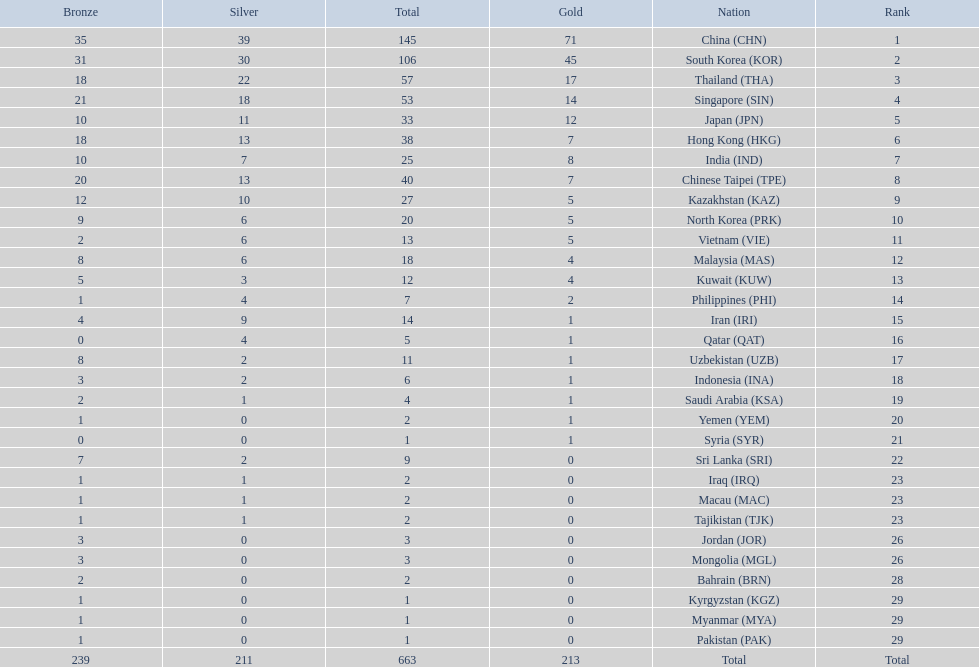How many countries have at least 10 gold medals in the asian youth games? 5. 